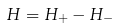<formula> <loc_0><loc_0><loc_500><loc_500>H = H _ { + } - H _ { - }</formula> 